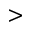Convert formula to latex. <formula><loc_0><loc_0><loc_500><loc_500>></formula> 